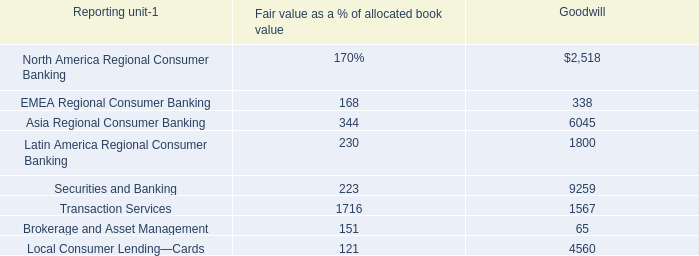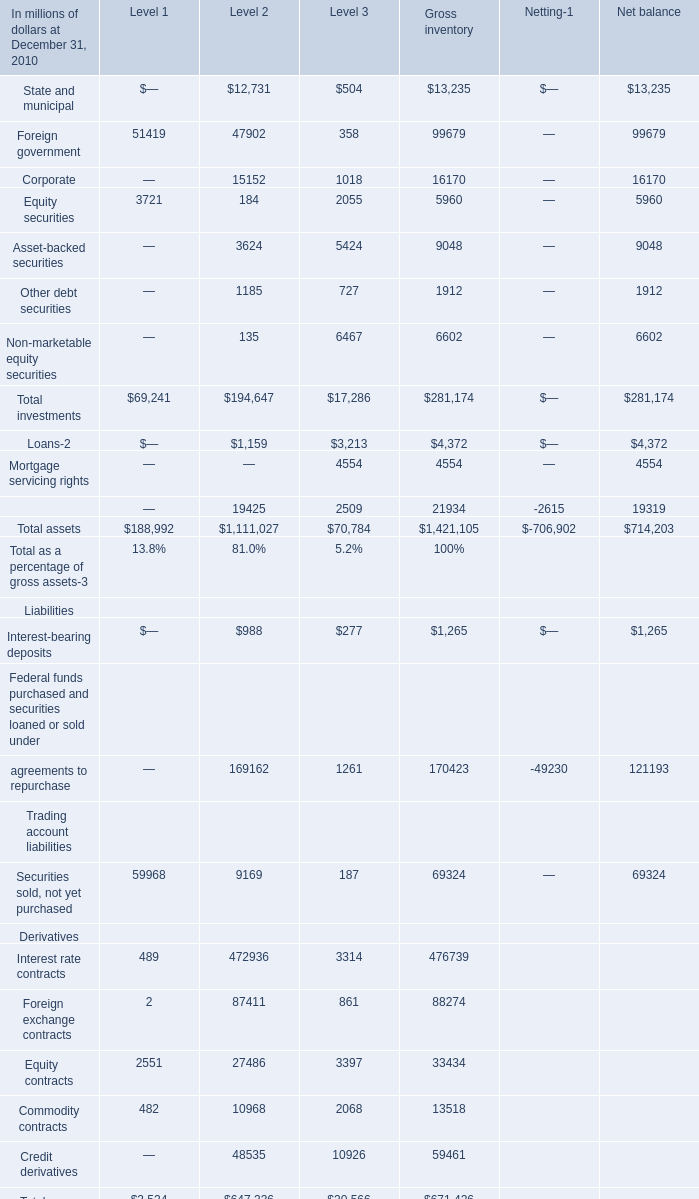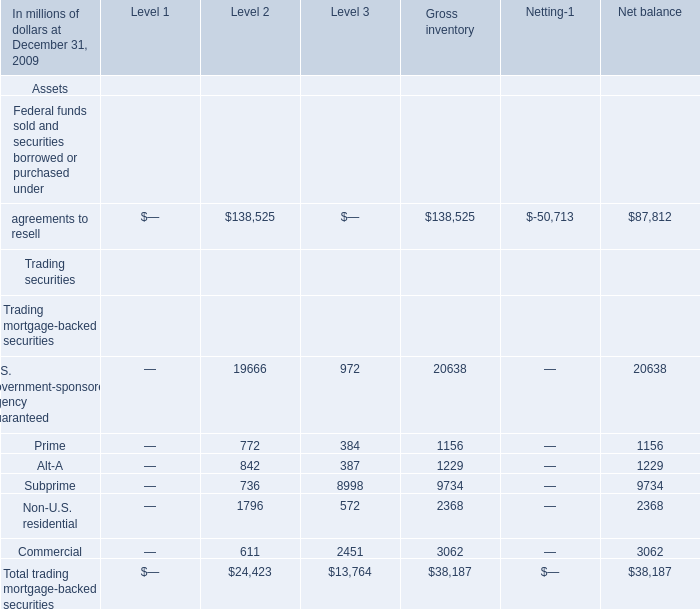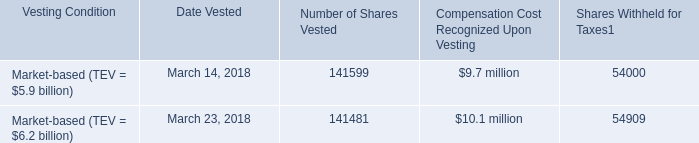What is the total amount of agreements to resell of Net balance, and Foreign government of Gross inventory ? 
Computations: (87812.0 + 99679.0)
Answer: 187491.0. 